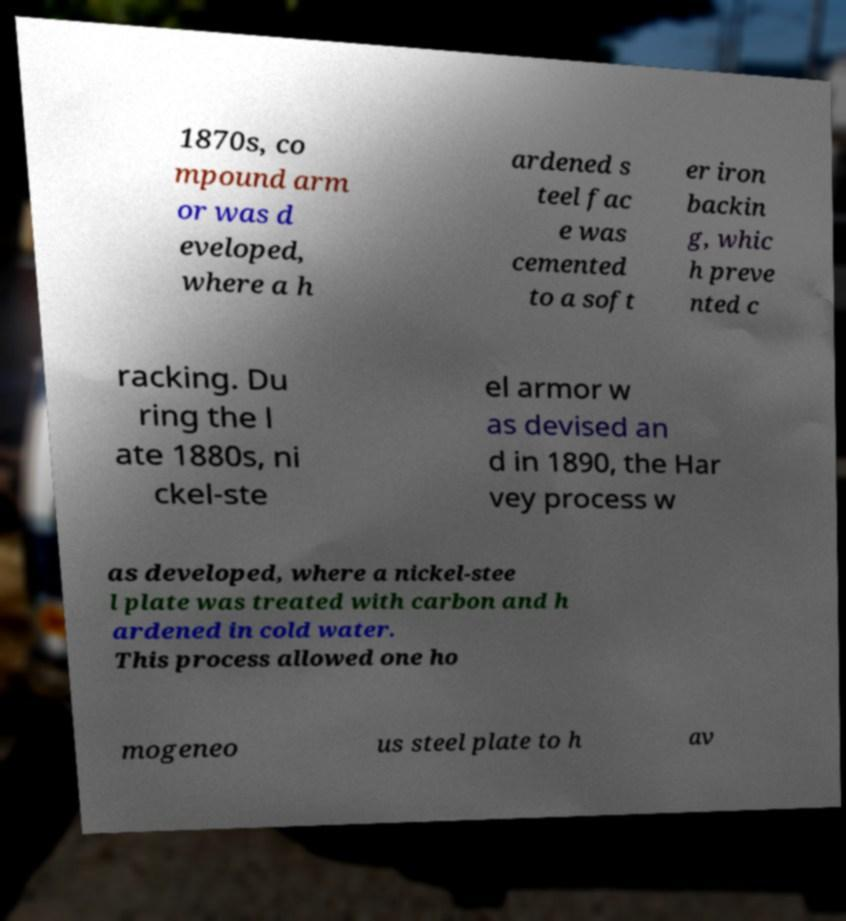Please read and relay the text visible in this image. What does it say? 1870s, co mpound arm or was d eveloped, where a h ardened s teel fac e was cemented to a soft er iron backin g, whic h preve nted c racking. Du ring the l ate 1880s, ni ckel-ste el armor w as devised an d in 1890, the Har vey process w as developed, where a nickel-stee l plate was treated with carbon and h ardened in cold water. This process allowed one ho mogeneo us steel plate to h av 